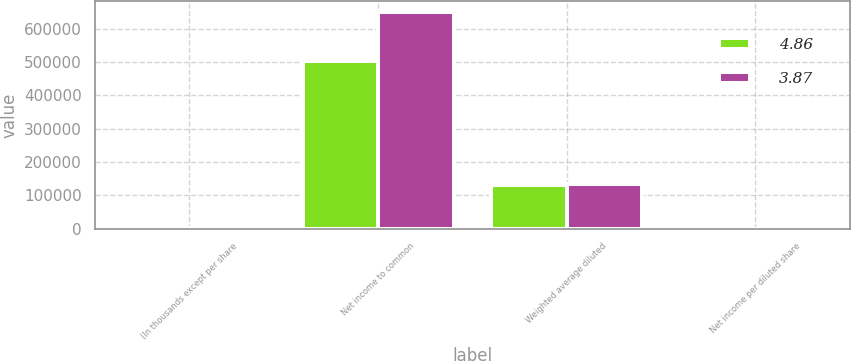<chart> <loc_0><loc_0><loc_500><loc_500><stacked_bar_chart><ecel><fcel>(In thousands except per share<fcel>Net income to common<fcel>Weighted average diluted<fcel>Net income per diluted share<nl><fcel>4.86<fcel>2015<fcel>503694<fcel>130189<fcel>3.87<nl><fcel>3.87<fcel>2014<fcel>648884<fcel>133652<fcel>4.86<nl></chart> 